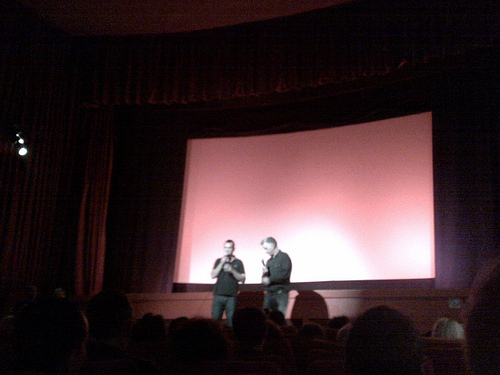<image>
Is the man on the screen? No. The man is not positioned on the screen. They may be near each other, but the man is not supported by or resting on top of the screen. 